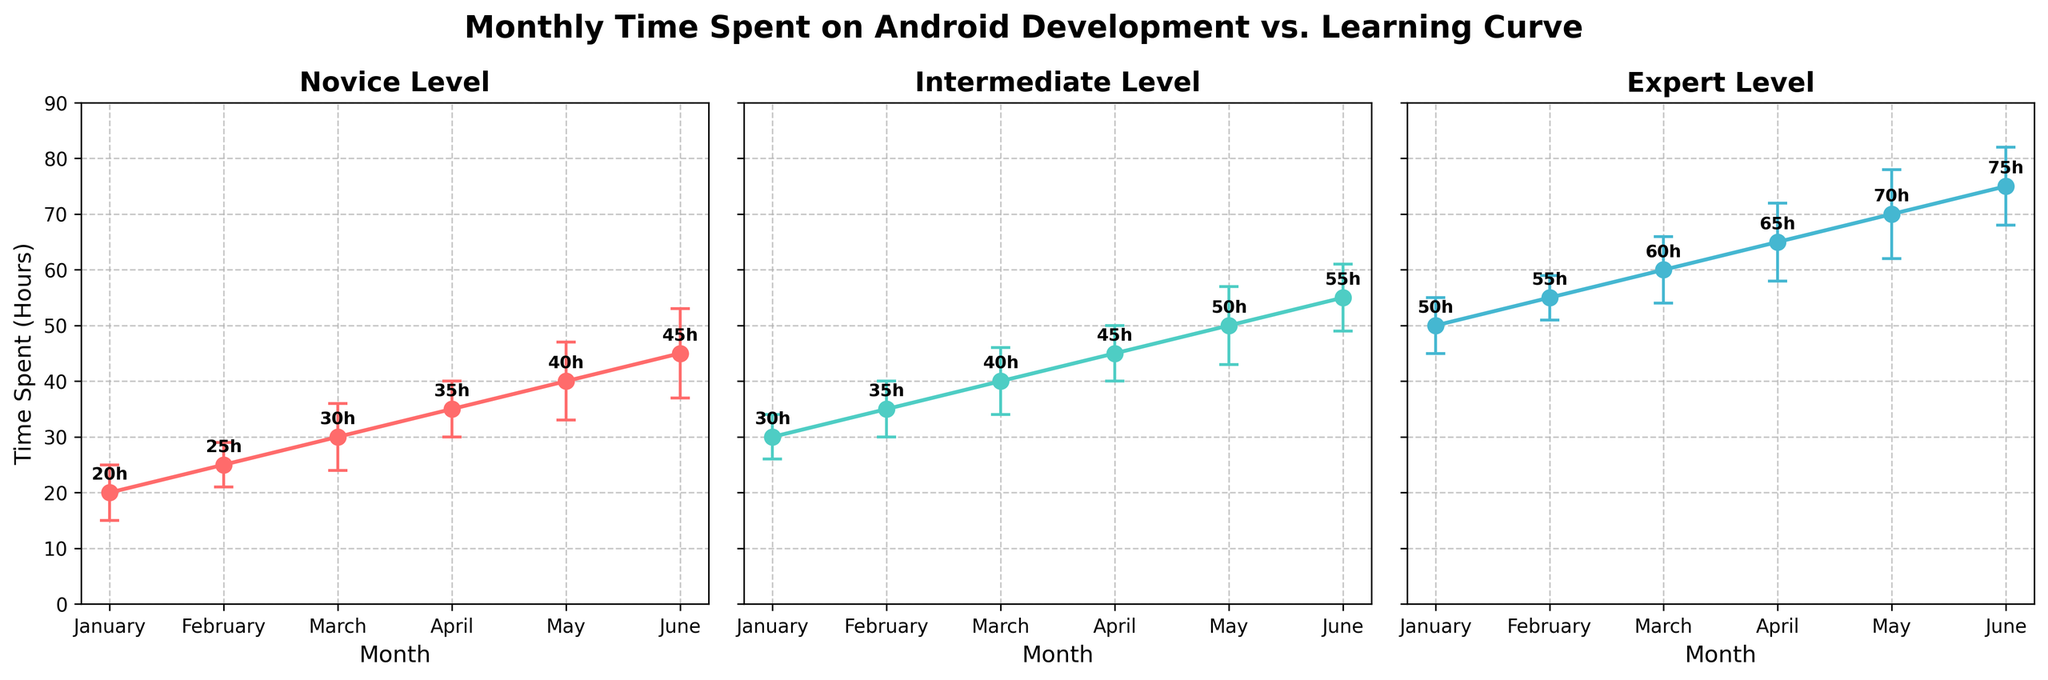What is the title of the figure? The title is usually located at the top center of the figure. It is meant to give a brief overview of what the figure is about.
Answer: Monthly Time Spent on Android Development vs. Learning Curve Which level has the highest time spent in June? To answer this, observe the June data points for each of the three subplots and identify the highest value.
Answer: Expert What is the time spent on Android development for Novice level in March? For this, look at the data point corresponding to March in the subplot for the Novice level.
Answer: 30 hours How many data points are shown for each level? Count the number of points in any of the subplots as they all display the same number of points.
Answer: 6 Which level shows the greatest increase in time spent from January to June? Compare the difference in time spent from January to June for Novice, Intermediate, and Expert levels by looking at the start and end points.
Answer: Expert Which level has the smallest error bars for the majority of the months? To determine this, examine the size of the error bars for each level and see which level consistently has smaller error bars.
Answer: Intermediate What is the total time spent on Android development by Intermediate level from January to June? Add the data points for each month from January to June for the Intermediate level: 30 + 35 + 40 + 45 + 50 + 55.
Answer: 255 hours Compare the time spent for Novice and Intermediate levels in April. Which level has more hours and by how much? Find the values for April in both subplots and calculate the difference. Novice: 35 hours, Intermediate: 45 hours. Difference: 45 - 35.
Answer: Intermediate, by 10 hours What is the average time spent on Android development by Expert level across all months shown? Sum up the time spent for each month at the Expert level and divide by the number of months: (50+55+60+65+70+75)/6.
Answer: 62.5 hours Which month had the least amount of time spent on Android development across all levels? Compare the data points for each level and month to find the smallest value.
Answer: January (Novice, 20 hours) 